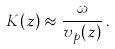Convert formula to latex. <formula><loc_0><loc_0><loc_500><loc_500>K ( z ) \approx \frac { \omega } { v _ { p } ( z ) } \, .</formula> 